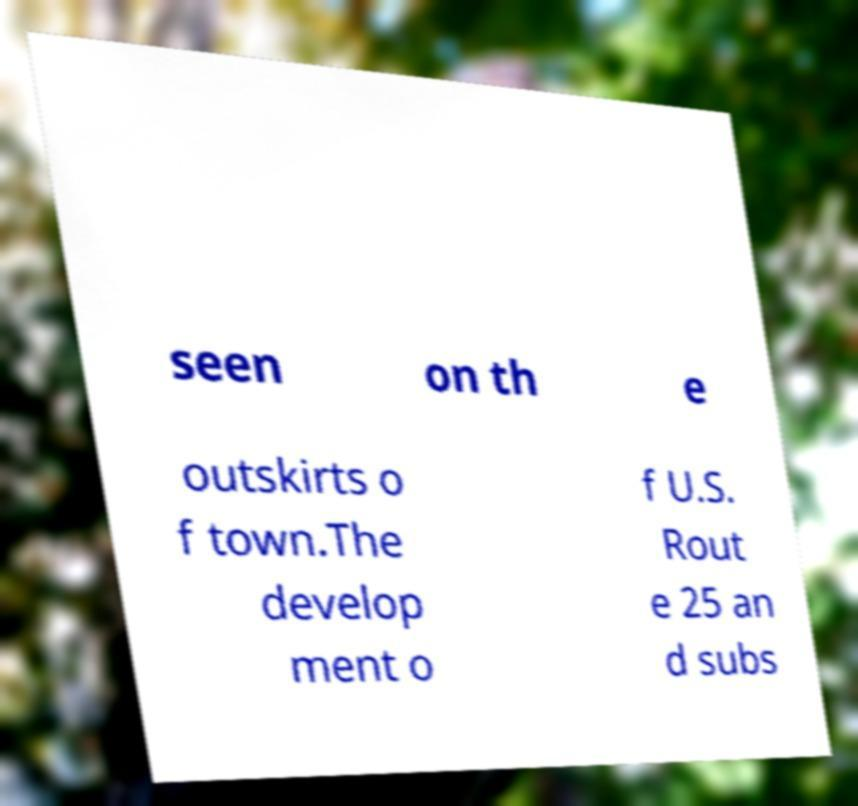What messages or text are displayed in this image? I need them in a readable, typed format. seen on th e outskirts o f town.The develop ment o f U.S. Rout e 25 an d subs 